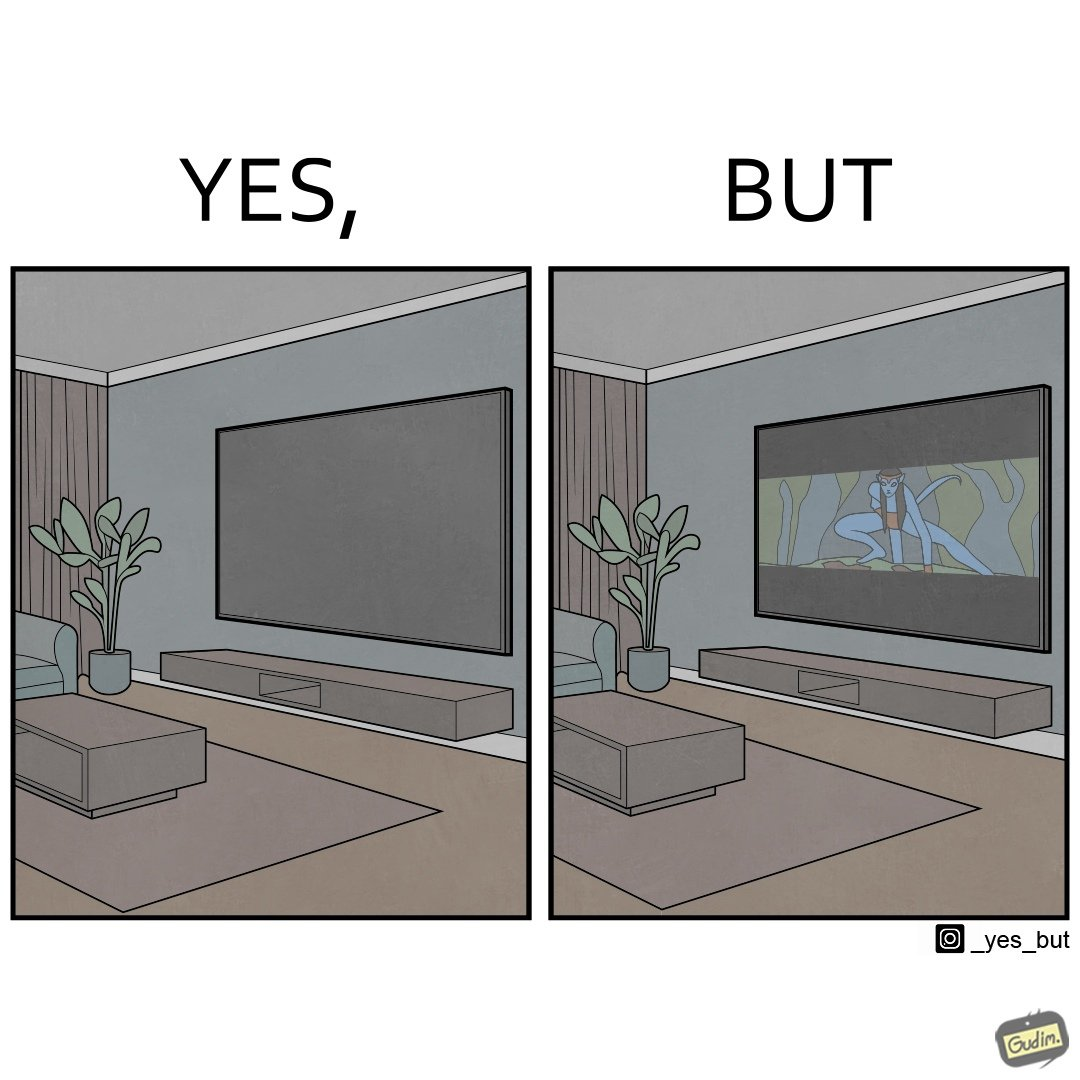What do you see in each half of this image? In the left part of the image: The image shows the living area in a home. The room has a big TV hanging on the wall. In the right part of the image: The image shows the living area in a home. The room has a big TV hanging on the wall playing a movie. The movie is not using the entire screen and top and bottom areas of the screen is unused. 